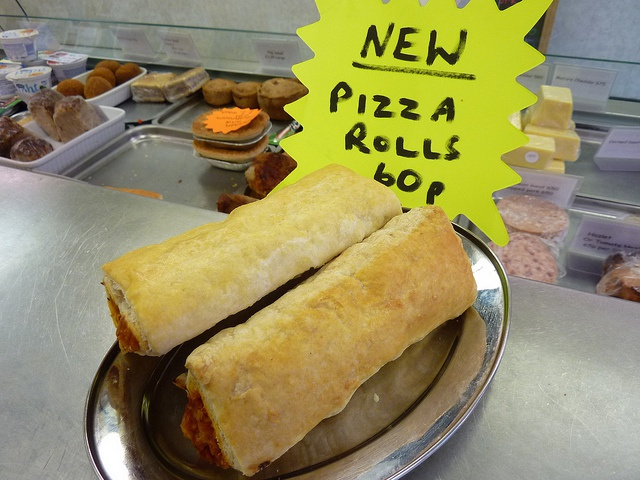Describe the objects in this image and their specific colors. I can see sandwich in gray, tan, and olive tones, sandwich in gray, tan, and khaki tones, sandwich in gray, orange, olive, and maroon tones, sandwich in gray and olive tones, and sandwich in gray, tan, and olive tones in this image. 